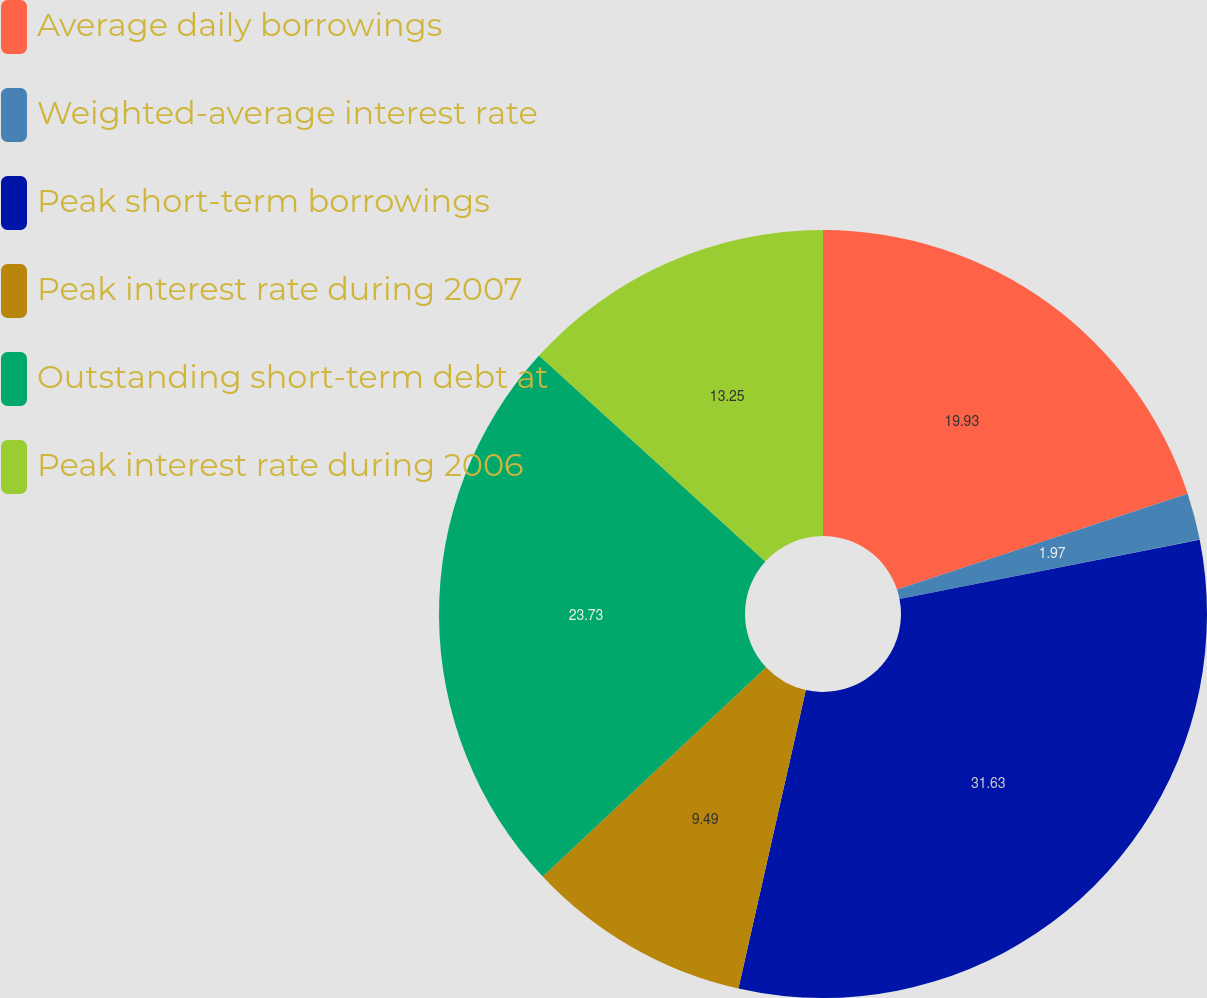<chart> <loc_0><loc_0><loc_500><loc_500><pie_chart><fcel>Average daily borrowings<fcel>Weighted-average interest rate<fcel>Peak short-term borrowings<fcel>Peak interest rate during 2007<fcel>Outstanding short-term debt at<fcel>Peak interest rate during 2006<nl><fcel>19.93%<fcel>1.97%<fcel>31.64%<fcel>9.49%<fcel>23.73%<fcel>13.25%<nl></chart> 